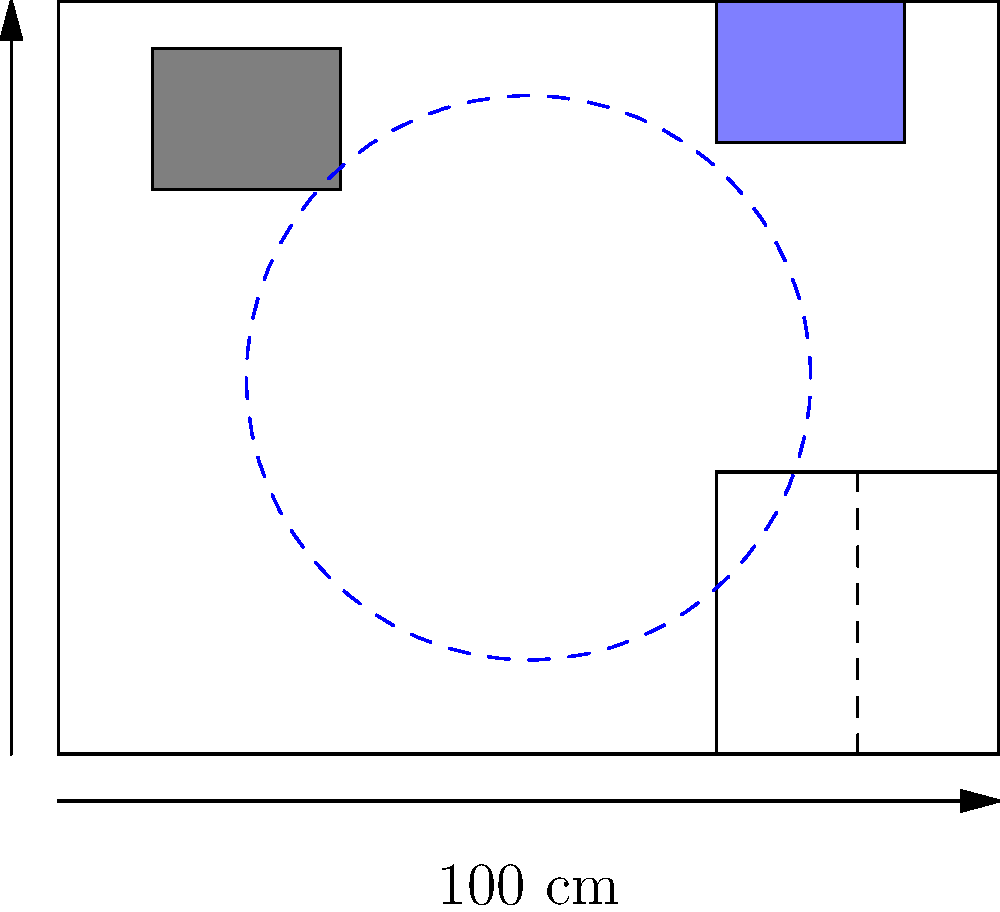In designing an accessible bathroom for a patient with mobility issues, what is the minimum diameter of the turning circle required for a wheelchair user, and why is it important to include this feature in the layout? To design an accessible bathroom for patients with mobility issues, several key factors need to be considered:

1. Turning Circle: The most crucial element in an accessible bathroom design is the turning circle. This is the clear floor space required for a wheelchair user to make a complete 360-degree turn.

2. Standard Requirement: According to the Americans with Disabilities Act (ADA) guidelines, the minimum diameter for a turning circle is 60 inches (152.4 cm).

3. Importance:
   a) Maneuverability: It allows wheelchair users to enter, turn around, and exit the bathroom independently.
   b) Access to Fixtures: Enables users to approach and use all fixtures (toilet, sink, shower) from different angles.
   c) Safety: Provides enough space for caregivers to assist if needed.

4. Layout Considerations:
   a) The turning circle should not overlap with the swing of the door.
   b) It should ideally be centrally located to provide access to all fixtures.
   c) The space under wall-mounted sinks can be included in the turning circle area.

5. Other Accessibility Features:
   a) Doorway: Minimum clear width of 32 inches (81.28 cm).
   b) Toilet: Centered 16-18 inches (40.64-45.72 cm) from the side wall.
   c) Grab Bars: Installed near the toilet and in the shower area.
   d) Shower: Roll-in design with a minimum size of 30x60 inches (76.2x152.4 cm).

6. In the provided layout:
   a) The turning circle is represented by the dashed blue circle in the center.
   b) Its diameter is 60 inches (152.4 cm), meeting the ADA requirement.
   c) It provides access to all fixtures without obstruction.

By incorporating a proper turning circle and other accessibility features, the bathroom design ensures that patients with mobility issues can use the facilities safely and independently, which is crucial for their dignity and quality of life.
Answer: 60 inches (152.4 cm) diameter; essential for wheelchair maneuverability and access to all fixtures. 